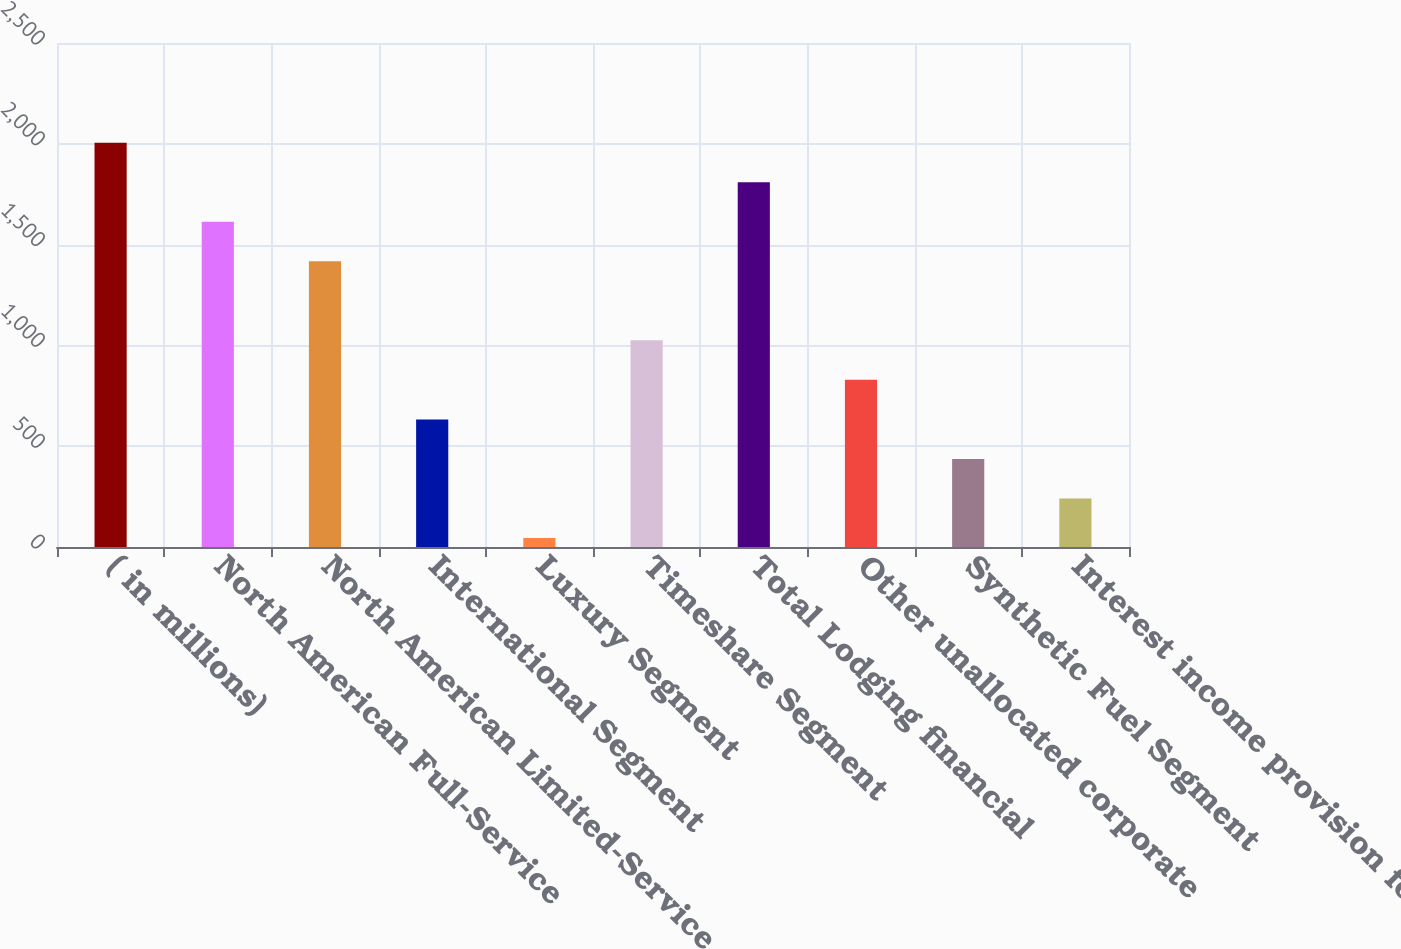Convert chart to OTSL. <chart><loc_0><loc_0><loc_500><loc_500><bar_chart><fcel>( in millions)<fcel>North American Full-Service<fcel>North American Limited-Service<fcel>International Segment<fcel>Luxury Segment<fcel>Timeshare Segment<fcel>Total Lodging financial<fcel>Other unallocated corporate<fcel>Synthetic Fuel Segment<fcel>Interest income provision for<nl><fcel>2005<fcel>1613<fcel>1417<fcel>633<fcel>45<fcel>1025<fcel>1809<fcel>829<fcel>437<fcel>241<nl></chart> 